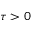Convert formula to latex. <formula><loc_0><loc_0><loc_500><loc_500>\tau > 0</formula> 